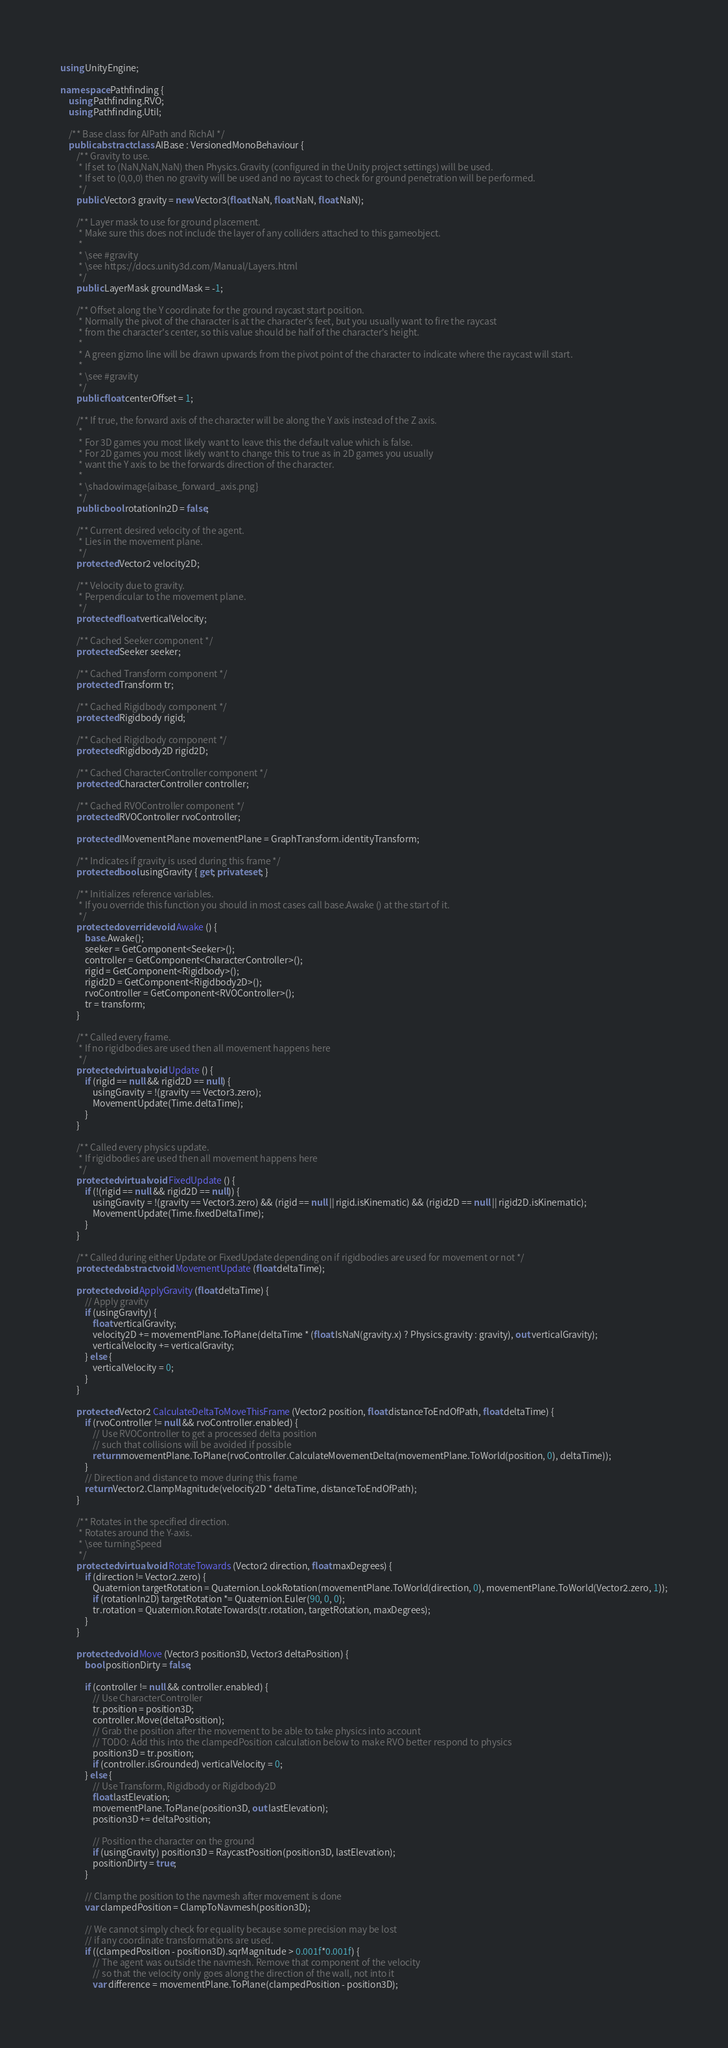Convert code to text. <code><loc_0><loc_0><loc_500><loc_500><_C#_>using UnityEngine;

namespace Pathfinding {
	using Pathfinding.RVO;
	using Pathfinding.Util;

	/** Base class for AIPath and RichAI */
	public abstract class AIBase : VersionedMonoBehaviour {
		/** Gravity to use.
		 * If set to (NaN,NaN,NaN) then Physics.Gravity (configured in the Unity project settings) will be used.
		 * If set to (0,0,0) then no gravity will be used and no raycast to check for ground penetration will be performed.
		 */
		public Vector3 gravity = new Vector3(float.NaN, float.NaN, float.NaN);

		/** Layer mask to use for ground placement.
		 * Make sure this does not include the layer of any colliders attached to this gameobject.
		 *
		 * \see #gravity
		 * \see https://docs.unity3d.com/Manual/Layers.html
		 */
		public LayerMask groundMask = -1;

		/** Offset along the Y coordinate for the ground raycast start position.
		 * Normally the pivot of the character is at the character's feet, but you usually want to fire the raycast
		 * from the character's center, so this value should be half of the character's height.
		 *
		 * A green gizmo line will be drawn upwards from the pivot point of the character to indicate where the raycast will start.
		 *
		 * \see #gravity
		 */
		public float centerOffset = 1;

		/** If true, the forward axis of the character will be along the Y axis instead of the Z axis.
		 *
		 * For 3D games you most likely want to leave this the default value which is false.
		 * For 2D games you most likely want to change this to true as in 2D games you usually
		 * want the Y axis to be the forwards direction of the character.
		 *
		 * \shadowimage{aibase_forward_axis.png}
		 */
		public bool rotationIn2D = false;

		/** Current desired velocity of the agent.
		 * Lies in the movement plane.
		 */
		protected Vector2 velocity2D;

		/** Velocity due to gravity.
		 * Perpendicular to the movement plane.
		 */
		protected float verticalVelocity;

		/** Cached Seeker component */
		protected Seeker seeker;

		/** Cached Transform component */
		protected Transform tr;

		/** Cached Rigidbody component */
		protected Rigidbody rigid;

		/** Cached Rigidbody component */
		protected Rigidbody2D rigid2D;

		/** Cached CharacterController component */
		protected CharacterController controller;

		/** Cached RVOController component */
		protected RVOController rvoController;

		protected IMovementPlane movementPlane = GraphTransform.identityTransform;

		/** Indicates if gravity is used during this frame */
		protected bool usingGravity { get; private set; }

		/** Initializes reference variables.
		 * If you override this function you should in most cases call base.Awake () at the start of it.
		 */
		protected override void Awake () {
			base.Awake();
			seeker = GetComponent<Seeker>();
			controller = GetComponent<CharacterController>();
			rigid = GetComponent<Rigidbody>();
			rigid2D = GetComponent<Rigidbody2D>();
			rvoController = GetComponent<RVOController>();
			tr = transform;
		}

		/** Called every frame.
		 * If no rigidbodies are used then all movement happens here
		 */
		protected virtual void Update () {
			if (rigid == null && rigid2D == null) {
				usingGravity = !(gravity == Vector3.zero);
				MovementUpdate(Time.deltaTime);
			}
		}

		/** Called every physics update.
		 * If rigidbodies are used then all movement happens here
		 */
		protected virtual void FixedUpdate () {
			if (!(rigid == null && rigid2D == null)) {
				usingGravity = !(gravity == Vector3.zero) && (rigid == null || rigid.isKinematic) && (rigid2D == null || rigid2D.isKinematic);
				MovementUpdate(Time.fixedDeltaTime);
			}
		}

		/** Called during either Update or FixedUpdate depending on if rigidbodies are used for movement or not */
		protected abstract void MovementUpdate (float deltaTime);

		protected void ApplyGravity (float deltaTime) {
			// Apply gravity
			if (usingGravity) {
				float verticalGravity;
				velocity2D += movementPlane.ToPlane(deltaTime * (float.IsNaN(gravity.x) ? Physics.gravity : gravity), out verticalGravity);
				verticalVelocity += verticalGravity;
			} else {
				verticalVelocity = 0;
			}
		}

		protected Vector2 CalculateDeltaToMoveThisFrame (Vector2 position, float distanceToEndOfPath, float deltaTime) {
			if (rvoController != null && rvoController.enabled) {
				// Use RVOController to get a processed delta position
				// such that collisions will be avoided if possible
				return movementPlane.ToPlane(rvoController.CalculateMovementDelta(movementPlane.ToWorld(position, 0), deltaTime));
			}
			// Direction and distance to move during this frame
			return Vector2.ClampMagnitude(velocity2D * deltaTime, distanceToEndOfPath);
		}

		/** Rotates in the specified direction.
		 * Rotates around the Y-axis.
		 * \see turningSpeed
		 */
		protected virtual void RotateTowards (Vector2 direction, float maxDegrees) {
			if (direction != Vector2.zero) {
				Quaternion targetRotation = Quaternion.LookRotation(movementPlane.ToWorld(direction, 0), movementPlane.ToWorld(Vector2.zero, 1));
				if (rotationIn2D) targetRotation *= Quaternion.Euler(90, 0, 0);
				tr.rotation = Quaternion.RotateTowards(tr.rotation, targetRotation, maxDegrees);
			}
		}

		protected void Move (Vector3 position3D, Vector3 deltaPosition) {
			bool positionDirty = false;

			if (controller != null && controller.enabled) {
				// Use CharacterController
				tr.position = position3D;
				controller.Move(deltaPosition);
				// Grab the position after the movement to be able to take physics into account
				// TODO: Add this into the clampedPosition calculation below to make RVO better respond to physics
				position3D = tr.position;
				if (controller.isGrounded) verticalVelocity = 0;
			} else {
				// Use Transform, Rigidbody or Rigidbody2D
				float lastElevation;
				movementPlane.ToPlane(position3D, out lastElevation);
				position3D += deltaPosition;

				// Position the character on the ground
				if (usingGravity) position3D = RaycastPosition(position3D, lastElevation);
				positionDirty = true;
			}

			// Clamp the position to the navmesh after movement is done
			var clampedPosition = ClampToNavmesh(position3D);

			// We cannot simply check for equality because some precision may be lost
			// if any coordinate transformations are used.
			if ((clampedPosition - position3D).sqrMagnitude > 0.001f*0.001f) {
				// The agent was outside the navmesh. Remove that component of the velocity
				// so that the velocity only goes along the direction of the wall, not into it
				var difference = movementPlane.ToPlane(clampedPosition - position3D);</code> 